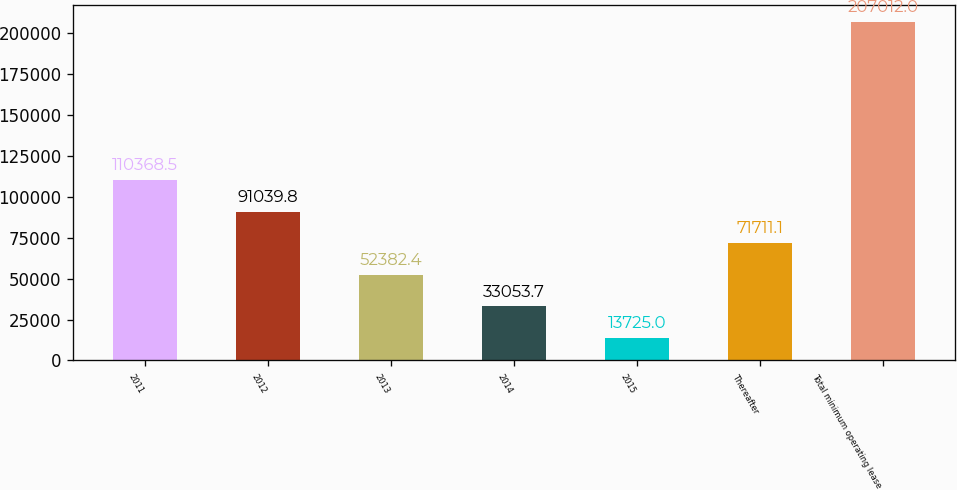Convert chart. <chart><loc_0><loc_0><loc_500><loc_500><bar_chart><fcel>2011<fcel>2012<fcel>2013<fcel>2014<fcel>2015<fcel>Thereafter<fcel>Total minimum operating lease<nl><fcel>110368<fcel>91039.8<fcel>52382.4<fcel>33053.7<fcel>13725<fcel>71711.1<fcel>207012<nl></chart> 